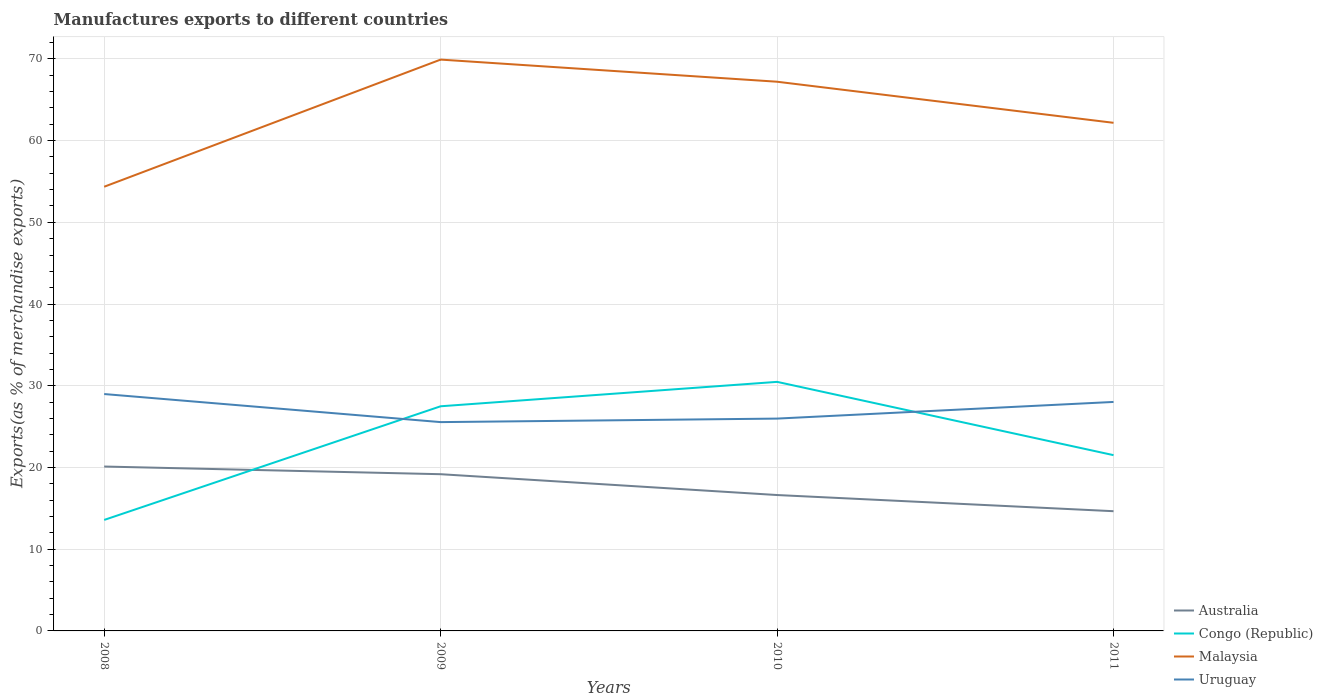How many different coloured lines are there?
Your answer should be very brief. 4. Is the number of lines equal to the number of legend labels?
Your answer should be compact. Yes. Across all years, what is the maximum percentage of exports to different countries in Australia?
Provide a short and direct response. 14.65. In which year was the percentage of exports to different countries in Malaysia maximum?
Offer a very short reply. 2008. What is the total percentage of exports to different countries in Malaysia in the graph?
Your answer should be compact. -12.85. What is the difference between the highest and the second highest percentage of exports to different countries in Uruguay?
Your answer should be very brief. 3.44. What is the difference between the highest and the lowest percentage of exports to different countries in Malaysia?
Your answer should be very brief. 2. Is the percentage of exports to different countries in Malaysia strictly greater than the percentage of exports to different countries in Australia over the years?
Provide a short and direct response. No. How many lines are there?
Provide a succinct answer. 4. How many years are there in the graph?
Your answer should be very brief. 4. What is the difference between two consecutive major ticks on the Y-axis?
Your response must be concise. 10. Are the values on the major ticks of Y-axis written in scientific E-notation?
Your answer should be compact. No. Does the graph contain any zero values?
Your answer should be very brief. No. Does the graph contain grids?
Offer a very short reply. Yes. How are the legend labels stacked?
Offer a very short reply. Vertical. What is the title of the graph?
Provide a succinct answer. Manufactures exports to different countries. Does "Eritrea" appear as one of the legend labels in the graph?
Provide a short and direct response. No. What is the label or title of the X-axis?
Your answer should be very brief. Years. What is the label or title of the Y-axis?
Make the answer very short. Exports(as % of merchandise exports). What is the Exports(as % of merchandise exports) of Australia in 2008?
Offer a very short reply. 20.12. What is the Exports(as % of merchandise exports) in Congo (Republic) in 2008?
Keep it short and to the point. 13.58. What is the Exports(as % of merchandise exports) of Malaysia in 2008?
Offer a terse response. 54.35. What is the Exports(as % of merchandise exports) of Uruguay in 2008?
Provide a short and direct response. 28.99. What is the Exports(as % of merchandise exports) in Australia in 2009?
Provide a short and direct response. 19.18. What is the Exports(as % of merchandise exports) of Congo (Republic) in 2009?
Your response must be concise. 27.49. What is the Exports(as % of merchandise exports) in Malaysia in 2009?
Keep it short and to the point. 69.91. What is the Exports(as % of merchandise exports) in Uruguay in 2009?
Give a very brief answer. 25.55. What is the Exports(as % of merchandise exports) of Australia in 2010?
Offer a terse response. 16.63. What is the Exports(as % of merchandise exports) of Congo (Republic) in 2010?
Your answer should be very brief. 30.48. What is the Exports(as % of merchandise exports) of Malaysia in 2010?
Give a very brief answer. 67.2. What is the Exports(as % of merchandise exports) of Uruguay in 2010?
Your answer should be very brief. 25.98. What is the Exports(as % of merchandise exports) in Australia in 2011?
Give a very brief answer. 14.65. What is the Exports(as % of merchandise exports) in Congo (Republic) in 2011?
Provide a succinct answer. 21.51. What is the Exports(as % of merchandise exports) in Malaysia in 2011?
Your answer should be compact. 62.18. What is the Exports(as % of merchandise exports) in Uruguay in 2011?
Keep it short and to the point. 28.02. Across all years, what is the maximum Exports(as % of merchandise exports) in Australia?
Ensure brevity in your answer.  20.12. Across all years, what is the maximum Exports(as % of merchandise exports) in Congo (Republic)?
Offer a terse response. 30.48. Across all years, what is the maximum Exports(as % of merchandise exports) of Malaysia?
Provide a short and direct response. 69.91. Across all years, what is the maximum Exports(as % of merchandise exports) of Uruguay?
Your answer should be compact. 28.99. Across all years, what is the minimum Exports(as % of merchandise exports) of Australia?
Keep it short and to the point. 14.65. Across all years, what is the minimum Exports(as % of merchandise exports) in Congo (Republic)?
Ensure brevity in your answer.  13.58. Across all years, what is the minimum Exports(as % of merchandise exports) in Malaysia?
Your answer should be very brief. 54.35. Across all years, what is the minimum Exports(as % of merchandise exports) in Uruguay?
Offer a terse response. 25.55. What is the total Exports(as % of merchandise exports) in Australia in the graph?
Your answer should be compact. 70.57. What is the total Exports(as % of merchandise exports) in Congo (Republic) in the graph?
Provide a succinct answer. 93.06. What is the total Exports(as % of merchandise exports) of Malaysia in the graph?
Keep it short and to the point. 253.65. What is the total Exports(as % of merchandise exports) in Uruguay in the graph?
Offer a terse response. 108.54. What is the difference between the Exports(as % of merchandise exports) in Australia in 2008 and that in 2009?
Give a very brief answer. 0.94. What is the difference between the Exports(as % of merchandise exports) in Congo (Republic) in 2008 and that in 2009?
Offer a terse response. -13.91. What is the difference between the Exports(as % of merchandise exports) of Malaysia in 2008 and that in 2009?
Give a very brief answer. -15.56. What is the difference between the Exports(as % of merchandise exports) of Uruguay in 2008 and that in 2009?
Your answer should be compact. 3.44. What is the difference between the Exports(as % of merchandise exports) in Australia in 2008 and that in 2010?
Provide a succinct answer. 3.49. What is the difference between the Exports(as % of merchandise exports) in Congo (Republic) in 2008 and that in 2010?
Your answer should be very brief. -16.9. What is the difference between the Exports(as % of merchandise exports) in Malaysia in 2008 and that in 2010?
Your answer should be compact. -12.85. What is the difference between the Exports(as % of merchandise exports) in Uruguay in 2008 and that in 2010?
Provide a succinct answer. 3. What is the difference between the Exports(as % of merchandise exports) in Australia in 2008 and that in 2011?
Offer a very short reply. 5.47. What is the difference between the Exports(as % of merchandise exports) in Congo (Republic) in 2008 and that in 2011?
Make the answer very short. -7.93. What is the difference between the Exports(as % of merchandise exports) in Malaysia in 2008 and that in 2011?
Offer a terse response. -7.82. What is the difference between the Exports(as % of merchandise exports) in Uruguay in 2008 and that in 2011?
Provide a succinct answer. 0.97. What is the difference between the Exports(as % of merchandise exports) of Australia in 2009 and that in 2010?
Your answer should be very brief. 2.55. What is the difference between the Exports(as % of merchandise exports) of Congo (Republic) in 2009 and that in 2010?
Your answer should be very brief. -2.99. What is the difference between the Exports(as % of merchandise exports) of Malaysia in 2009 and that in 2010?
Ensure brevity in your answer.  2.71. What is the difference between the Exports(as % of merchandise exports) in Uruguay in 2009 and that in 2010?
Provide a short and direct response. -0.43. What is the difference between the Exports(as % of merchandise exports) in Australia in 2009 and that in 2011?
Provide a succinct answer. 4.53. What is the difference between the Exports(as % of merchandise exports) in Congo (Republic) in 2009 and that in 2011?
Give a very brief answer. 5.98. What is the difference between the Exports(as % of merchandise exports) in Malaysia in 2009 and that in 2011?
Offer a very short reply. 7.74. What is the difference between the Exports(as % of merchandise exports) of Uruguay in 2009 and that in 2011?
Provide a short and direct response. -2.47. What is the difference between the Exports(as % of merchandise exports) in Australia in 2010 and that in 2011?
Your response must be concise. 1.98. What is the difference between the Exports(as % of merchandise exports) of Congo (Republic) in 2010 and that in 2011?
Offer a terse response. 8.97. What is the difference between the Exports(as % of merchandise exports) in Malaysia in 2010 and that in 2011?
Your answer should be very brief. 5.03. What is the difference between the Exports(as % of merchandise exports) of Uruguay in 2010 and that in 2011?
Ensure brevity in your answer.  -2.04. What is the difference between the Exports(as % of merchandise exports) of Australia in 2008 and the Exports(as % of merchandise exports) of Congo (Republic) in 2009?
Provide a short and direct response. -7.37. What is the difference between the Exports(as % of merchandise exports) of Australia in 2008 and the Exports(as % of merchandise exports) of Malaysia in 2009?
Offer a terse response. -49.8. What is the difference between the Exports(as % of merchandise exports) of Australia in 2008 and the Exports(as % of merchandise exports) of Uruguay in 2009?
Offer a very short reply. -5.44. What is the difference between the Exports(as % of merchandise exports) of Congo (Republic) in 2008 and the Exports(as % of merchandise exports) of Malaysia in 2009?
Provide a succinct answer. -56.33. What is the difference between the Exports(as % of merchandise exports) in Congo (Republic) in 2008 and the Exports(as % of merchandise exports) in Uruguay in 2009?
Give a very brief answer. -11.97. What is the difference between the Exports(as % of merchandise exports) of Malaysia in 2008 and the Exports(as % of merchandise exports) of Uruguay in 2009?
Your response must be concise. 28.8. What is the difference between the Exports(as % of merchandise exports) of Australia in 2008 and the Exports(as % of merchandise exports) of Congo (Republic) in 2010?
Offer a terse response. -10.36. What is the difference between the Exports(as % of merchandise exports) in Australia in 2008 and the Exports(as % of merchandise exports) in Malaysia in 2010?
Give a very brief answer. -47.09. What is the difference between the Exports(as % of merchandise exports) of Australia in 2008 and the Exports(as % of merchandise exports) of Uruguay in 2010?
Provide a succinct answer. -5.87. What is the difference between the Exports(as % of merchandise exports) in Congo (Republic) in 2008 and the Exports(as % of merchandise exports) in Malaysia in 2010?
Make the answer very short. -53.62. What is the difference between the Exports(as % of merchandise exports) in Congo (Republic) in 2008 and the Exports(as % of merchandise exports) in Uruguay in 2010?
Ensure brevity in your answer.  -12.4. What is the difference between the Exports(as % of merchandise exports) of Malaysia in 2008 and the Exports(as % of merchandise exports) of Uruguay in 2010?
Provide a succinct answer. 28.37. What is the difference between the Exports(as % of merchandise exports) of Australia in 2008 and the Exports(as % of merchandise exports) of Congo (Republic) in 2011?
Offer a very short reply. -1.39. What is the difference between the Exports(as % of merchandise exports) of Australia in 2008 and the Exports(as % of merchandise exports) of Malaysia in 2011?
Ensure brevity in your answer.  -42.06. What is the difference between the Exports(as % of merchandise exports) of Australia in 2008 and the Exports(as % of merchandise exports) of Uruguay in 2011?
Provide a succinct answer. -7.91. What is the difference between the Exports(as % of merchandise exports) of Congo (Republic) in 2008 and the Exports(as % of merchandise exports) of Malaysia in 2011?
Keep it short and to the point. -48.59. What is the difference between the Exports(as % of merchandise exports) in Congo (Republic) in 2008 and the Exports(as % of merchandise exports) in Uruguay in 2011?
Your response must be concise. -14.44. What is the difference between the Exports(as % of merchandise exports) in Malaysia in 2008 and the Exports(as % of merchandise exports) in Uruguay in 2011?
Give a very brief answer. 26.33. What is the difference between the Exports(as % of merchandise exports) in Australia in 2009 and the Exports(as % of merchandise exports) in Congo (Republic) in 2010?
Your answer should be very brief. -11.3. What is the difference between the Exports(as % of merchandise exports) in Australia in 2009 and the Exports(as % of merchandise exports) in Malaysia in 2010?
Make the answer very short. -48.03. What is the difference between the Exports(as % of merchandise exports) in Australia in 2009 and the Exports(as % of merchandise exports) in Uruguay in 2010?
Provide a short and direct response. -6.8. What is the difference between the Exports(as % of merchandise exports) of Congo (Republic) in 2009 and the Exports(as % of merchandise exports) of Malaysia in 2010?
Make the answer very short. -39.71. What is the difference between the Exports(as % of merchandise exports) in Congo (Republic) in 2009 and the Exports(as % of merchandise exports) in Uruguay in 2010?
Offer a very short reply. 1.51. What is the difference between the Exports(as % of merchandise exports) in Malaysia in 2009 and the Exports(as % of merchandise exports) in Uruguay in 2010?
Provide a short and direct response. 43.93. What is the difference between the Exports(as % of merchandise exports) of Australia in 2009 and the Exports(as % of merchandise exports) of Congo (Republic) in 2011?
Your response must be concise. -2.33. What is the difference between the Exports(as % of merchandise exports) of Australia in 2009 and the Exports(as % of merchandise exports) of Malaysia in 2011?
Provide a short and direct response. -43. What is the difference between the Exports(as % of merchandise exports) of Australia in 2009 and the Exports(as % of merchandise exports) of Uruguay in 2011?
Provide a short and direct response. -8.84. What is the difference between the Exports(as % of merchandise exports) of Congo (Republic) in 2009 and the Exports(as % of merchandise exports) of Malaysia in 2011?
Make the answer very short. -34.69. What is the difference between the Exports(as % of merchandise exports) of Congo (Republic) in 2009 and the Exports(as % of merchandise exports) of Uruguay in 2011?
Your response must be concise. -0.53. What is the difference between the Exports(as % of merchandise exports) in Malaysia in 2009 and the Exports(as % of merchandise exports) in Uruguay in 2011?
Offer a terse response. 41.89. What is the difference between the Exports(as % of merchandise exports) in Australia in 2010 and the Exports(as % of merchandise exports) in Congo (Republic) in 2011?
Provide a short and direct response. -4.88. What is the difference between the Exports(as % of merchandise exports) in Australia in 2010 and the Exports(as % of merchandise exports) in Malaysia in 2011?
Provide a succinct answer. -45.55. What is the difference between the Exports(as % of merchandise exports) of Australia in 2010 and the Exports(as % of merchandise exports) of Uruguay in 2011?
Keep it short and to the point. -11.39. What is the difference between the Exports(as % of merchandise exports) in Congo (Republic) in 2010 and the Exports(as % of merchandise exports) in Malaysia in 2011?
Your answer should be very brief. -31.7. What is the difference between the Exports(as % of merchandise exports) in Congo (Republic) in 2010 and the Exports(as % of merchandise exports) in Uruguay in 2011?
Offer a very short reply. 2.46. What is the difference between the Exports(as % of merchandise exports) of Malaysia in 2010 and the Exports(as % of merchandise exports) of Uruguay in 2011?
Your response must be concise. 39.18. What is the average Exports(as % of merchandise exports) in Australia per year?
Ensure brevity in your answer.  17.64. What is the average Exports(as % of merchandise exports) in Congo (Republic) per year?
Provide a succinct answer. 23.26. What is the average Exports(as % of merchandise exports) of Malaysia per year?
Make the answer very short. 63.41. What is the average Exports(as % of merchandise exports) in Uruguay per year?
Provide a short and direct response. 27.14. In the year 2008, what is the difference between the Exports(as % of merchandise exports) of Australia and Exports(as % of merchandise exports) of Congo (Republic)?
Offer a very short reply. 6.53. In the year 2008, what is the difference between the Exports(as % of merchandise exports) in Australia and Exports(as % of merchandise exports) in Malaysia?
Ensure brevity in your answer.  -34.24. In the year 2008, what is the difference between the Exports(as % of merchandise exports) in Australia and Exports(as % of merchandise exports) in Uruguay?
Make the answer very short. -8.87. In the year 2008, what is the difference between the Exports(as % of merchandise exports) of Congo (Republic) and Exports(as % of merchandise exports) of Malaysia?
Keep it short and to the point. -40.77. In the year 2008, what is the difference between the Exports(as % of merchandise exports) of Congo (Republic) and Exports(as % of merchandise exports) of Uruguay?
Provide a succinct answer. -15.4. In the year 2008, what is the difference between the Exports(as % of merchandise exports) of Malaysia and Exports(as % of merchandise exports) of Uruguay?
Give a very brief answer. 25.37. In the year 2009, what is the difference between the Exports(as % of merchandise exports) in Australia and Exports(as % of merchandise exports) in Congo (Republic)?
Offer a very short reply. -8.31. In the year 2009, what is the difference between the Exports(as % of merchandise exports) of Australia and Exports(as % of merchandise exports) of Malaysia?
Offer a very short reply. -50.73. In the year 2009, what is the difference between the Exports(as % of merchandise exports) in Australia and Exports(as % of merchandise exports) in Uruguay?
Make the answer very short. -6.37. In the year 2009, what is the difference between the Exports(as % of merchandise exports) in Congo (Republic) and Exports(as % of merchandise exports) in Malaysia?
Provide a short and direct response. -42.42. In the year 2009, what is the difference between the Exports(as % of merchandise exports) of Congo (Republic) and Exports(as % of merchandise exports) of Uruguay?
Provide a succinct answer. 1.94. In the year 2009, what is the difference between the Exports(as % of merchandise exports) in Malaysia and Exports(as % of merchandise exports) in Uruguay?
Make the answer very short. 44.36. In the year 2010, what is the difference between the Exports(as % of merchandise exports) of Australia and Exports(as % of merchandise exports) of Congo (Republic)?
Your answer should be compact. -13.85. In the year 2010, what is the difference between the Exports(as % of merchandise exports) in Australia and Exports(as % of merchandise exports) in Malaysia?
Your answer should be very brief. -50.57. In the year 2010, what is the difference between the Exports(as % of merchandise exports) in Australia and Exports(as % of merchandise exports) in Uruguay?
Your answer should be very brief. -9.35. In the year 2010, what is the difference between the Exports(as % of merchandise exports) in Congo (Republic) and Exports(as % of merchandise exports) in Malaysia?
Offer a very short reply. -36.73. In the year 2010, what is the difference between the Exports(as % of merchandise exports) in Congo (Republic) and Exports(as % of merchandise exports) in Uruguay?
Your answer should be very brief. 4.5. In the year 2010, what is the difference between the Exports(as % of merchandise exports) of Malaysia and Exports(as % of merchandise exports) of Uruguay?
Ensure brevity in your answer.  41.22. In the year 2011, what is the difference between the Exports(as % of merchandise exports) in Australia and Exports(as % of merchandise exports) in Congo (Republic)?
Your answer should be compact. -6.86. In the year 2011, what is the difference between the Exports(as % of merchandise exports) in Australia and Exports(as % of merchandise exports) in Malaysia?
Make the answer very short. -47.53. In the year 2011, what is the difference between the Exports(as % of merchandise exports) in Australia and Exports(as % of merchandise exports) in Uruguay?
Offer a terse response. -13.37. In the year 2011, what is the difference between the Exports(as % of merchandise exports) in Congo (Republic) and Exports(as % of merchandise exports) in Malaysia?
Ensure brevity in your answer.  -40.67. In the year 2011, what is the difference between the Exports(as % of merchandise exports) in Congo (Republic) and Exports(as % of merchandise exports) in Uruguay?
Ensure brevity in your answer.  -6.51. In the year 2011, what is the difference between the Exports(as % of merchandise exports) in Malaysia and Exports(as % of merchandise exports) in Uruguay?
Offer a terse response. 34.16. What is the ratio of the Exports(as % of merchandise exports) in Australia in 2008 to that in 2009?
Keep it short and to the point. 1.05. What is the ratio of the Exports(as % of merchandise exports) of Congo (Republic) in 2008 to that in 2009?
Offer a terse response. 0.49. What is the ratio of the Exports(as % of merchandise exports) of Malaysia in 2008 to that in 2009?
Your response must be concise. 0.78. What is the ratio of the Exports(as % of merchandise exports) of Uruguay in 2008 to that in 2009?
Your response must be concise. 1.13. What is the ratio of the Exports(as % of merchandise exports) of Australia in 2008 to that in 2010?
Make the answer very short. 1.21. What is the ratio of the Exports(as % of merchandise exports) in Congo (Republic) in 2008 to that in 2010?
Your answer should be compact. 0.45. What is the ratio of the Exports(as % of merchandise exports) of Malaysia in 2008 to that in 2010?
Offer a terse response. 0.81. What is the ratio of the Exports(as % of merchandise exports) of Uruguay in 2008 to that in 2010?
Your answer should be compact. 1.12. What is the ratio of the Exports(as % of merchandise exports) in Australia in 2008 to that in 2011?
Make the answer very short. 1.37. What is the ratio of the Exports(as % of merchandise exports) of Congo (Republic) in 2008 to that in 2011?
Provide a short and direct response. 0.63. What is the ratio of the Exports(as % of merchandise exports) in Malaysia in 2008 to that in 2011?
Offer a very short reply. 0.87. What is the ratio of the Exports(as % of merchandise exports) in Uruguay in 2008 to that in 2011?
Your answer should be compact. 1.03. What is the ratio of the Exports(as % of merchandise exports) of Australia in 2009 to that in 2010?
Offer a very short reply. 1.15. What is the ratio of the Exports(as % of merchandise exports) of Congo (Republic) in 2009 to that in 2010?
Provide a succinct answer. 0.9. What is the ratio of the Exports(as % of merchandise exports) in Malaysia in 2009 to that in 2010?
Your answer should be compact. 1.04. What is the ratio of the Exports(as % of merchandise exports) of Uruguay in 2009 to that in 2010?
Your answer should be compact. 0.98. What is the ratio of the Exports(as % of merchandise exports) of Australia in 2009 to that in 2011?
Your answer should be compact. 1.31. What is the ratio of the Exports(as % of merchandise exports) of Congo (Republic) in 2009 to that in 2011?
Ensure brevity in your answer.  1.28. What is the ratio of the Exports(as % of merchandise exports) in Malaysia in 2009 to that in 2011?
Give a very brief answer. 1.12. What is the ratio of the Exports(as % of merchandise exports) in Uruguay in 2009 to that in 2011?
Provide a short and direct response. 0.91. What is the ratio of the Exports(as % of merchandise exports) in Australia in 2010 to that in 2011?
Your response must be concise. 1.14. What is the ratio of the Exports(as % of merchandise exports) of Congo (Republic) in 2010 to that in 2011?
Offer a terse response. 1.42. What is the ratio of the Exports(as % of merchandise exports) in Malaysia in 2010 to that in 2011?
Provide a short and direct response. 1.08. What is the ratio of the Exports(as % of merchandise exports) of Uruguay in 2010 to that in 2011?
Your response must be concise. 0.93. What is the difference between the highest and the second highest Exports(as % of merchandise exports) in Australia?
Make the answer very short. 0.94. What is the difference between the highest and the second highest Exports(as % of merchandise exports) in Congo (Republic)?
Give a very brief answer. 2.99. What is the difference between the highest and the second highest Exports(as % of merchandise exports) in Malaysia?
Your response must be concise. 2.71. What is the difference between the highest and the second highest Exports(as % of merchandise exports) of Uruguay?
Your response must be concise. 0.97. What is the difference between the highest and the lowest Exports(as % of merchandise exports) of Australia?
Give a very brief answer. 5.47. What is the difference between the highest and the lowest Exports(as % of merchandise exports) of Congo (Republic)?
Provide a short and direct response. 16.9. What is the difference between the highest and the lowest Exports(as % of merchandise exports) of Malaysia?
Offer a terse response. 15.56. What is the difference between the highest and the lowest Exports(as % of merchandise exports) in Uruguay?
Give a very brief answer. 3.44. 